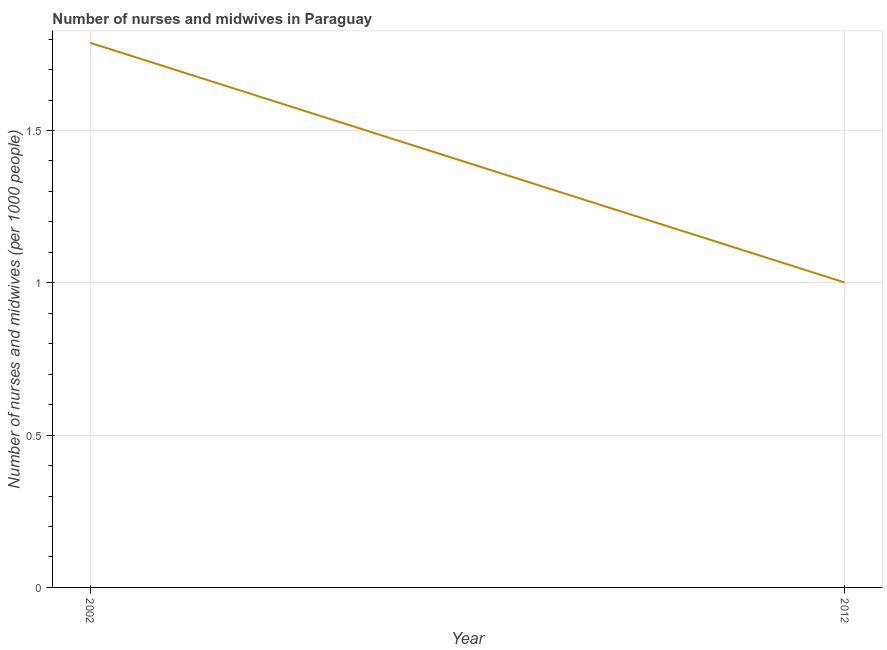What is the number of nurses and midwives in 2012?
Ensure brevity in your answer.  1. Across all years, what is the maximum number of nurses and midwives?
Ensure brevity in your answer.  1.79. In which year was the number of nurses and midwives minimum?
Your response must be concise. 2012. What is the sum of the number of nurses and midwives?
Keep it short and to the point. 2.79. What is the difference between the number of nurses and midwives in 2002 and 2012?
Your response must be concise. 0.79. What is the average number of nurses and midwives per year?
Provide a succinct answer. 1.39. What is the median number of nurses and midwives?
Offer a very short reply. 1.39. In how many years, is the number of nurses and midwives greater than 1 ?
Your answer should be compact. 2. What is the ratio of the number of nurses and midwives in 2002 to that in 2012?
Your response must be concise. 1.79. What is the difference between two consecutive major ticks on the Y-axis?
Give a very brief answer. 0.5. What is the title of the graph?
Make the answer very short. Number of nurses and midwives in Paraguay. What is the label or title of the Y-axis?
Your answer should be compact. Number of nurses and midwives (per 1000 people). What is the Number of nurses and midwives (per 1000 people) in 2002?
Provide a succinct answer. 1.79. What is the difference between the Number of nurses and midwives (per 1000 people) in 2002 and 2012?
Ensure brevity in your answer.  0.79. What is the ratio of the Number of nurses and midwives (per 1000 people) in 2002 to that in 2012?
Your answer should be very brief. 1.79. 